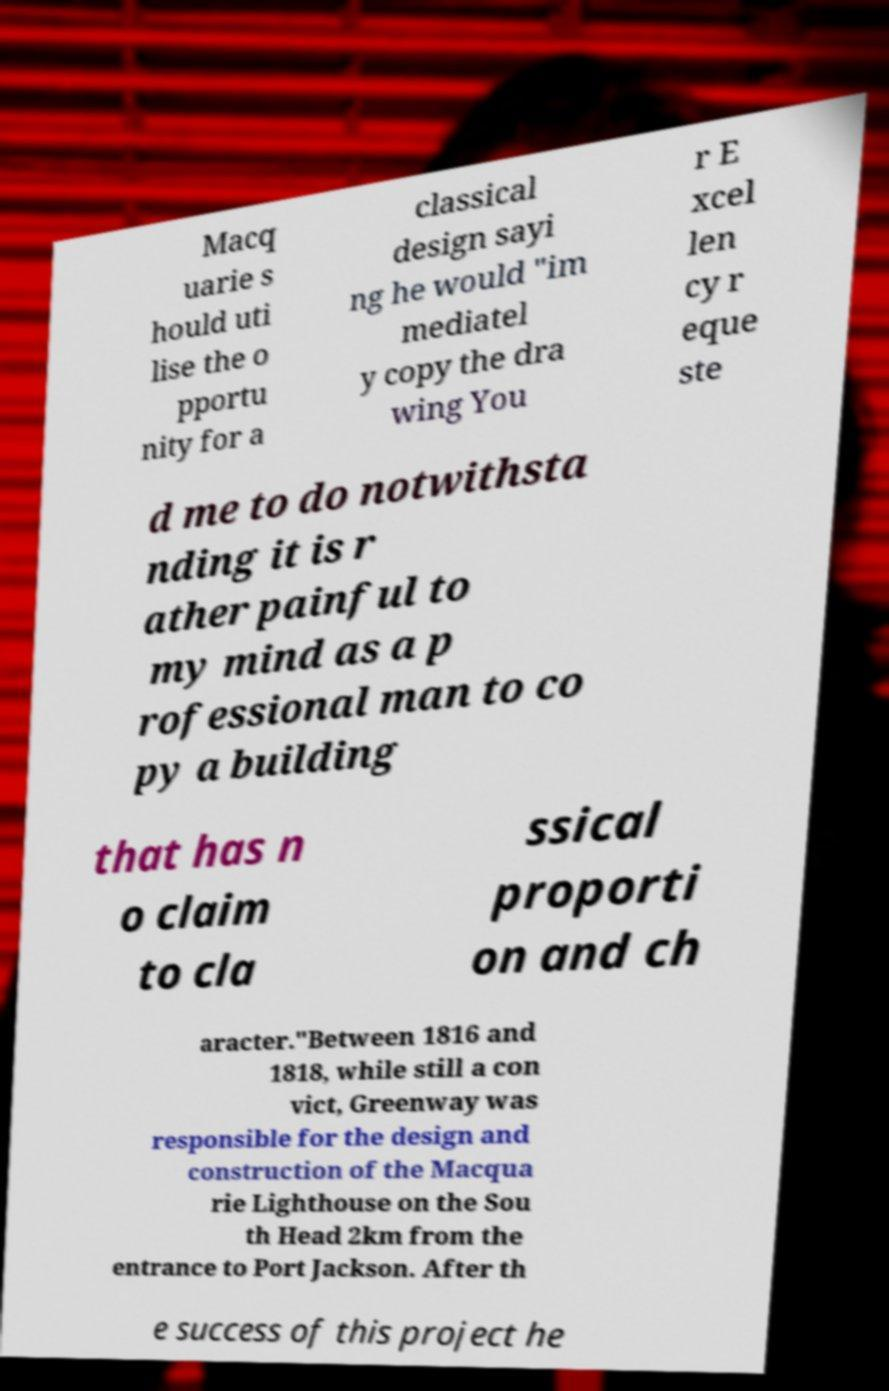Could you extract and type out the text from this image? Macq uarie s hould uti lise the o pportu nity for a classical design sayi ng he would "im mediatel y copy the dra wing You r E xcel len cy r eque ste d me to do notwithsta nding it is r ather painful to my mind as a p rofessional man to co py a building that has n o claim to cla ssical proporti on and ch aracter."Between 1816 and 1818, while still a con vict, Greenway was responsible for the design and construction of the Macqua rie Lighthouse on the Sou th Head 2km from the entrance to Port Jackson. After th e success of this project he 